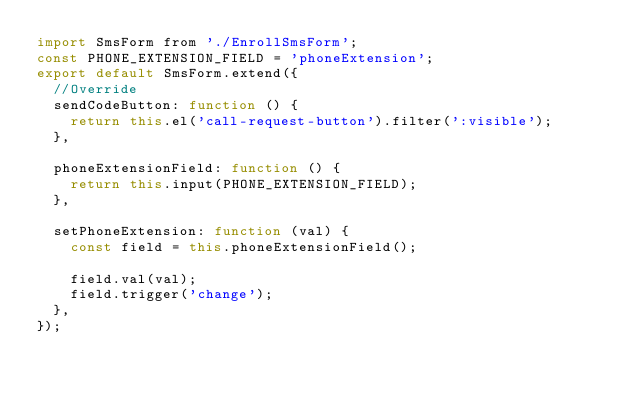<code> <loc_0><loc_0><loc_500><loc_500><_JavaScript_>import SmsForm from './EnrollSmsForm';
const PHONE_EXTENSION_FIELD = 'phoneExtension';
export default SmsForm.extend({
  //Override
  sendCodeButton: function () {
    return this.el('call-request-button').filter(':visible');
  },

  phoneExtensionField: function () {
    return this.input(PHONE_EXTENSION_FIELD);
  },

  setPhoneExtension: function (val) {
    const field = this.phoneExtensionField();

    field.val(val);
    field.trigger('change');
  },
});
</code> 